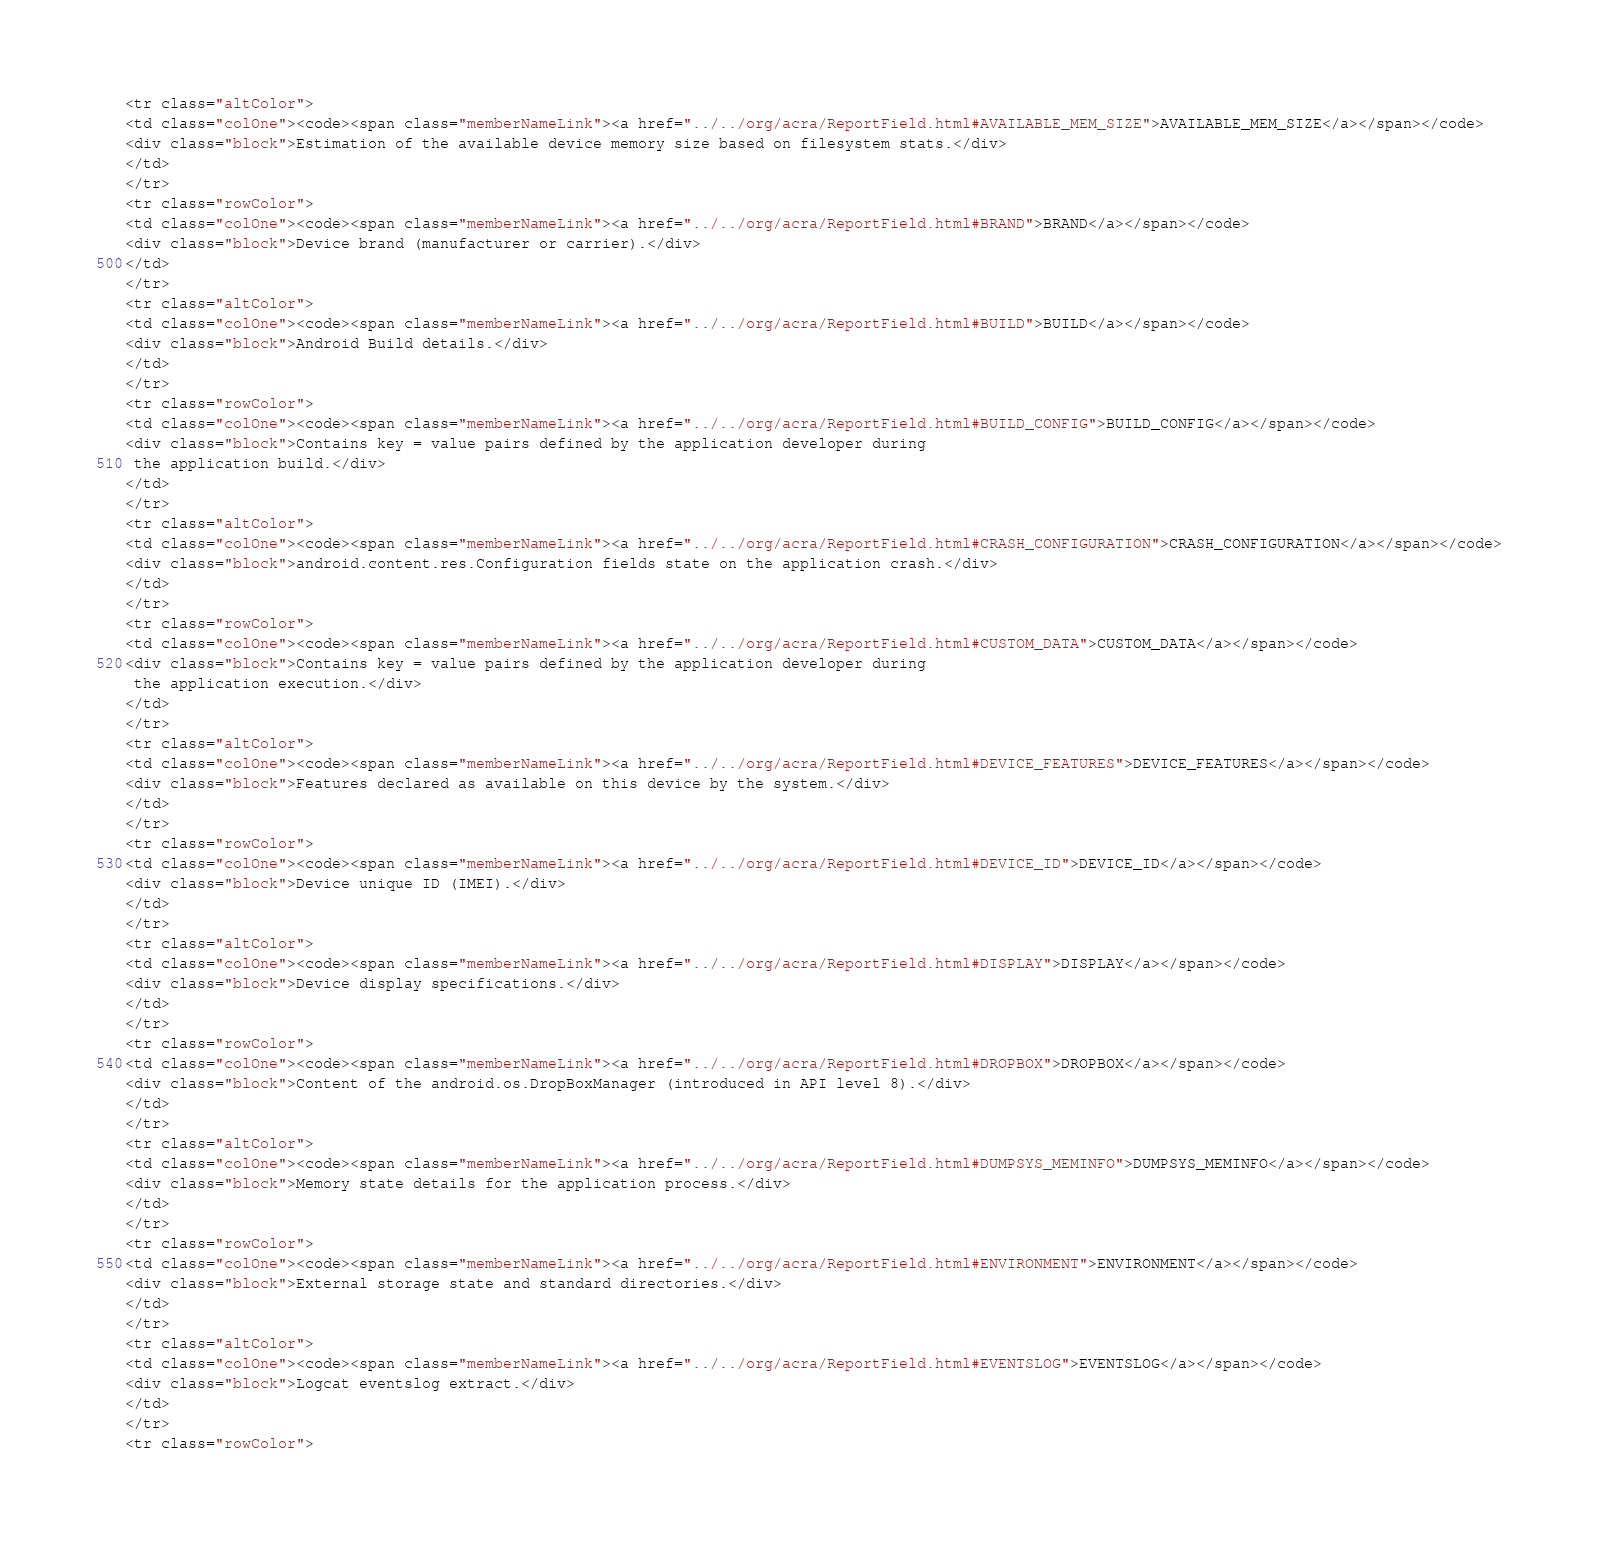<code> <loc_0><loc_0><loc_500><loc_500><_HTML_><tr class="altColor">
<td class="colOne"><code><span class="memberNameLink"><a href="../../org/acra/ReportField.html#AVAILABLE_MEM_SIZE">AVAILABLE_MEM_SIZE</a></span></code>
<div class="block">Estimation of the available device memory size based on filesystem stats.</div>
</td>
</tr>
<tr class="rowColor">
<td class="colOne"><code><span class="memberNameLink"><a href="../../org/acra/ReportField.html#BRAND">BRAND</a></span></code>
<div class="block">Device brand (manufacturer or carrier).</div>
</td>
</tr>
<tr class="altColor">
<td class="colOne"><code><span class="memberNameLink"><a href="../../org/acra/ReportField.html#BUILD">BUILD</a></span></code>
<div class="block">Android Build details.</div>
</td>
</tr>
<tr class="rowColor">
<td class="colOne"><code><span class="memberNameLink"><a href="../../org/acra/ReportField.html#BUILD_CONFIG">BUILD_CONFIG</a></span></code>
<div class="block">Contains key = value pairs defined by the application developer during
 the application build.</div>
</td>
</tr>
<tr class="altColor">
<td class="colOne"><code><span class="memberNameLink"><a href="../../org/acra/ReportField.html#CRASH_CONFIGURATION">CRASH_CONFIGURATION</a></span></code>
<div class="block">android.content.res.Configuration fields state on the application crash.</div>
</td>
</tr>
<tr class="rowColor">
<td class="colOne"><code><span class="memberNameLink"><a href="../../org/acra/ReportField.html#CUSTOM_DATA">CUSTOM_DATA</a></span></code>
<div class="block">Contains key = value pairs defined by the application developer during
 the application execution.</div>
</td>
</tr>
<tr class="altColor">
<td class="colOne"><code><span class="memberNameLink"><a href="../../org/acra/ReportField.html#DEVICE_FEATURES">DEVICE_FEATURES</a></span></code>
<div class="block">Features declared as available on this device by the system.</div>
</td>
</tr>
<tr class="rowColor">
<td class="colOne"><code><span class="memberNameLink"><a href="../../org/acra/ReportField.html#DEVICE_ID">DEVICE_ID</a></span></code>
<div class="block">Device unique ID (IMEI).</div>
</td>
</tr>
<tr class="altColor">
<td class="colOne"><code><span class="memberNameLink"><a href="../../org/acra/ReportField.html#DISPLAY">DISPLAY</a></span></code>
<div class="block">Device display specifications.</div>
</td>
</tr>
<tr class="rowColor">
<td class="colOne"><code><span class="memberNameLink"><a href="../../org/acra/ReportField.html#DROPBOX">DROPBOX</a></span></code>
<div class="block">Content of the android.os.DropBoxManager (introduced in API level 8).</div>
</td>
</tr>
<tr class="altColor">
<td class="colOne"><code><span class="memberNameLink"><a href="../../org/acra/ReportField.html#DUMPSYS_MEMINFO">DUMPSYS_MEMINFO</a></span></code>
<div class="block">Memory state details for the application process.</div>
</td>
</tr>
<tr class="rowColor">
<td class="colOne"><code><span class="memberNameLink"><a href="../../org/acra/ReportField.html#ENVIRONMENT">ENVIRONMENT</a></span></code>
<div class="block">External storage state and standard directories.</div>
</td>
</tr>
<tr class="altColor">
<td class="colOne"><code><span class="memberNameLink"><a href="../../org/acra/ReportField.html#EVENTSLOG">EVENTSLOG</a></span></code>
<div class="block">Logcat eventslog extract.</div>
</td>
</tr>
<tr class="rowColor"></code> 